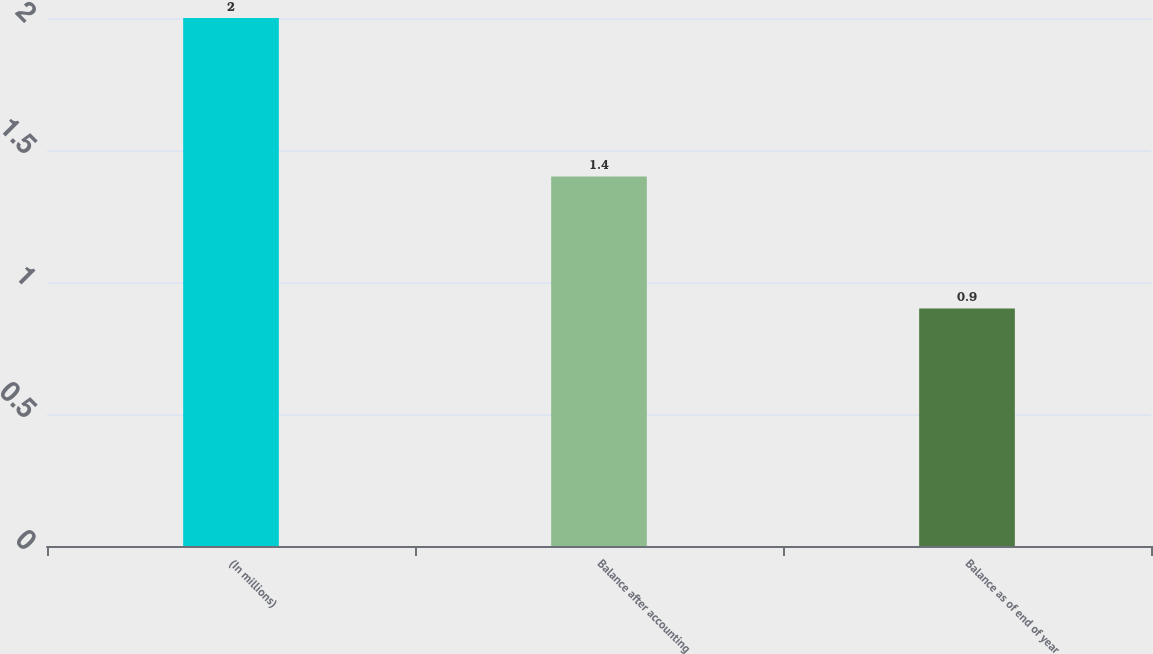<chart> <loc_0><loc_0><loc_500><loc_500><bar_chart><fcel>(In millions)<fcel>Balance after accounting<fcel>Balance as of end of year<nl><fcel>2<fcel>1.4<fcel>0.9<nl></chart> 